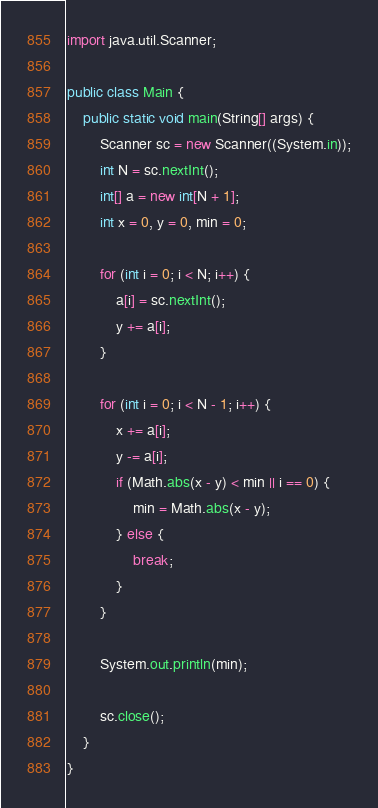Convert code to text. <code><loc_0><loc_0><loc_500><loc_500><_Java_>import java.util.Scanner;

public class Main {
	public static void main(String[] args) {
		Scanner sc = new Scanner((System.in));
		int N = sc.nextInt();
		int[] a = new int[N + 1];
		int x = 0, y = 0, min = 0;

		for (int i = 0; i < N; i++) {
			a[i] = sc.nextInt();
			y += a[i];
		}
		
		for (int i = 0; i < N - 1; i++) {
			x += a[i];
			y -= a[i];
			if (Math.abs(x - y) < min || i == 0) {
				min = Math.abs(x - y);
			} else {
				break;
			}
		}

		System.out.println(min);

		sc.close();
	}
}</code> 